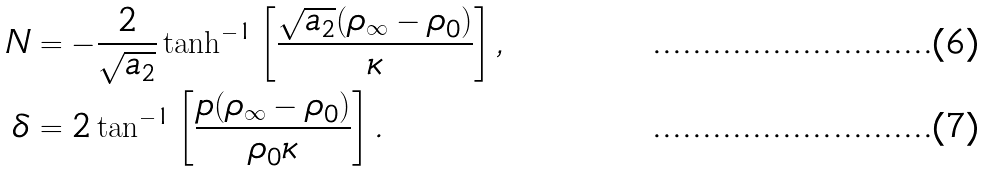Convert formula to latex. <formula><loc_0><loc_0><loc_500><loc_500>N & = - \frac { 2 } { \sqrt { a _ { 2 } } } \tanh ^ { - 1 } \left [ \frac { \sqrt { a _ { 2 } } ( \rho _ { \infty } - \rho _ { 0 } ) } { \kappa } \right ] , \\ \delta & = 2 \tan ^ { - 1 } \left [ \frac { p ( \rho _ { \infty } - \rho _ { 0 } ) } { \rho _ { 0 } \kappa } \right ] .</formula> 